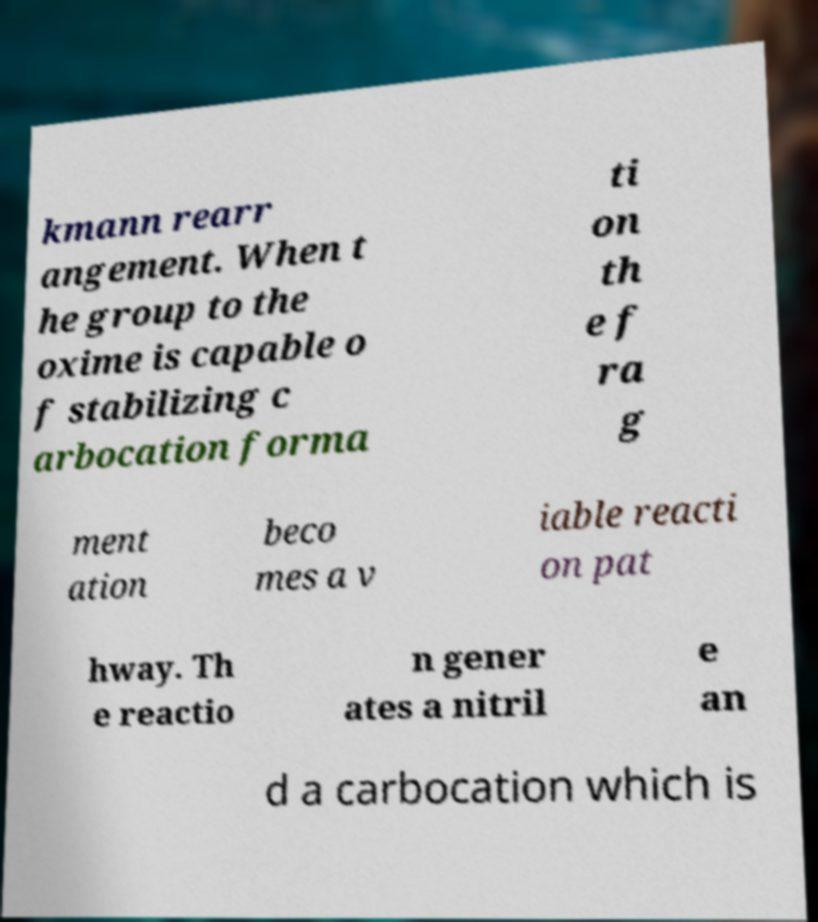Can you accurately transcribe the text from the provided image for me? kmann rearr angement. When t he group to the oxime is capable o f stabilizing c arbocation forma ti on th e f ra g ment ation beco mes a v iable reacti on pat hway. Th e reactio n gener ates a nitril e an d a carbocation which is 